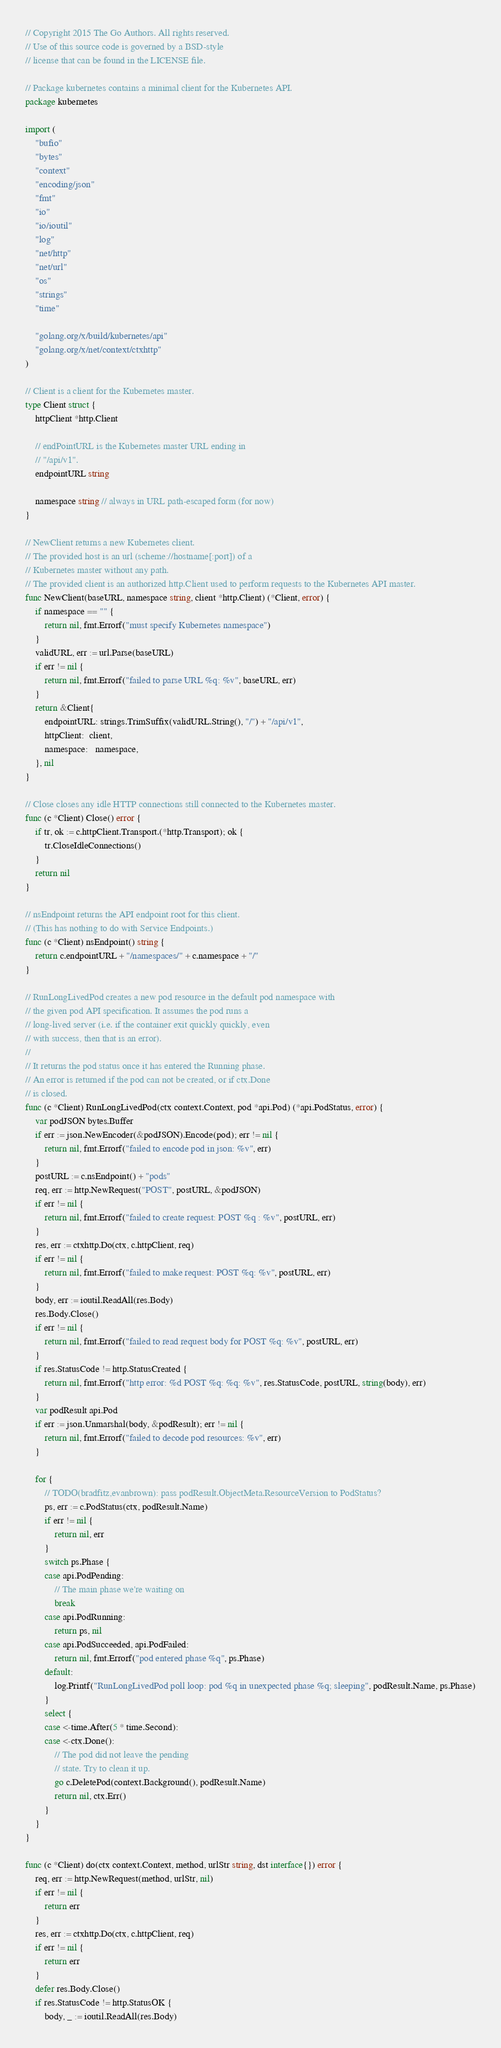<code> <loc_0><loc_0><loc_500><loc_500><_Go_>// Copyright 2015 The Go Authors. All rights reserved.
// Use of this source code is governed by a BSD-style
// license that can be found in the LICENSE file.

// Package kubernetes contains a minimal client for the Kubernetes API.
package kubernetes

import (
	"bufio"
	"bytes"
	"context"
	"encoding/json"
	"fmt"
	"io"
	"io/ioutil"
	"log"
	"net/http"
	"net/url"
	"os"
	"strings"
	"time"

	"golang.org/x/build/kubernetes/api"
	"golang.org/x/net/context/ctxhttp"
)

// Client is a client for the Kubernetes master.
type Client struct {
	httpClient *http.Client

	// endPointURL is the Kubernetes master URL ending in
	// "/api/v1".
	endpointURL string

	namespace string // always in URL path-escaped form (for now)
}

// NewClient returns a new Kubernetes client.
// The provided host is an url (scheme://hostname[:port]) of a
// Kubernetes master without any path.
// The provided client is an authorized http.Client used to perform requests to the Kubernetes API master.
func NewClient(baseURL, namespace string, client *http.Client) (*Client, error) {
	if namespace == "" {
		return nil, fmt.Errorf("must specify Kubernetes namespace")
	}
	validURL, err := url.Parse(baseURL)
	if err != nil {
		return nil, fmt.Errorf("failed to parse URL %q: %v", baseURL, err)
	}
	return &Client{
		endpointURL: strings.TrimSuffix(validURL.String(), "/") + "/api/v1",
		httpClient:  client,
		namespace:   namespace,
	}, nil
}

// Close closes any idle HTTP connections still connected to the Kubernetes master.
func (c *Client) Close() error {
	if tr, ok := c.httpClient.Transport.(*http.Transport); ok {
		tr.CloseIdleConnections()
	}
	return nil
}

// nsEndpoint returns the API endpoint root for this client.
// (This has nothing to do with Service Endpoints.)
func (c *Client) nsEndpoint() string {
	return c.endpointURL + "/namespaces/" + c.namespace + "/"
}

// RunLongLivedPod creates a new pod resource in the default pod namespace with
// the given pod API specification. It assumes the pod runs a
// long-lived server (i.e. if the container exit quickly quickly, even
// with success, then that is an error).
//
// It returns the pod status once it has entered the Running phase.
// An error is returned if the pod can not be created, or if ctx.Done
// is closed.
func (c *Client) RunLongLivedPod(ctx context.Context, pod *api.Pod) (*api.PodStatus, error) {
	var podJSON bytes.Buffer
	if err := json.NewEncoder(&podJSON).Encode(pod); err != nil {
		return nil, fmt.Errorf("failed to encode pod in json: %v", err)
	}
	postURL := c.nsEndpoint() + "pods"
	req, err := http.NewRequest("POST", postURL, &podJSON)
	if err != nil {
		return nil, fmt.Errorf("failed to create request: POST %q : %v", postURL, err)
	}
	res, err := ctxhttp.Do(ctx, c.httpClient, req)
	if err != nil {
		return nil, fmt.Errorf("failed to make request: POST %q: %v", postURL, err)
	}
	body, err := ioutil.ReadAll(res.Body)
	res.Body.Close()
	if err != nil {
		return nil, fmt.Errorf("failed to read request body for POST %q: %v", postURL, err)
	}
	if res.StatusCode != http.StatusCreated {
		return nil, fmt.Errorf("http error: %d POST %q: %q: %v", res.StatusCode, postURL, string(body), err)
	}
	var podResult api.Pod
	if err := json.Unmarshal(body, &podResult); err != nil {
		return nil, fmt.Errorf("failed to decode pod resources: %v", err)
	}

	for {
		// TODO(bradfitz,evanbrown): pass podResult.ObjectMeta.ResourceVersion to PodStatus?
		ps, err := c.PodStatus(ctx, podResult.Name)
		if err != nil {
			return nil, err
		}
		switch ps.Phase {
		case api.PodPending:
			// The main phase we're waiting on
			break
		case api.PodRunning:
			return ps, nil
		case api.PodSucceeded, api.PodFailed:
			return nil, fmt.Errorf("pod entered phase %q", ps.Phase)
		default:
			log.Printf("RunLongLivedPod poll loop: pod %q in unexpected phase %q; sleeping", podResult.Name, ps.Phase)
		}
		select {
		case <-time.After(5 * time.Second):
		case <-ctx.Done():
			// The pod did not leave the pending
			// state. Try to clean it up.
			go c.DeletePod(context.Background(), podResult.Name)
			return nil, ctx.Err()
		}
	}
}

func (c *Client) do(ctx context.Context, method, urlStr string, dst interface{}) error {
	req, err := http.NewRequest(method, urlStr, nil)
	if err != nil {
		return err
	}
	res, err := ctxhttp.Do(ctx, c.httpClient, req)
	if err != nil {
		return err
	}
	defer res.Body.Close()
	if res.StatusCode != http.StatusOK {
		body, _ := ioutil.ReadAll(res.Body)</code> 